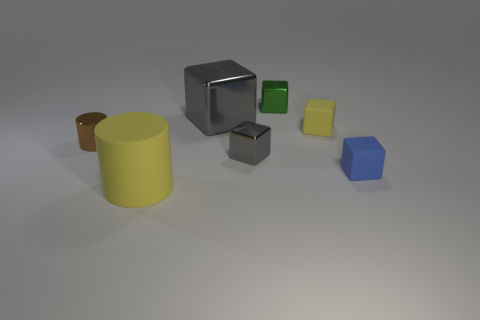There is a yellow object that is on the left side of the yellow object that is on the right side of the gray object that is in front of the brown object; what is it made of?
Ensure brevity in your answer.  Rubber. Does the green metal thing have the same shape as the blue matte thing?
Your response must be concise. Yes. What number of metal objects are either large purple spheres or yellow cubes?
Give a very brief answer. 0. What number of small cubes are there?
Make the answer very short. 4. There is another matte block that is the same size as the yellow matte block; what color is it?
Offer a terse response. Blue. Does the yellow cube have the same size as the green cube?
Your answer should be very brief. Yes. There is a blue matte cube; is its size the same as the yellow matte thing in front of the tiny blue matte block?
Provide a short and direct response. No. There is a block that is to the left of the green shiny thing and to the right of the large block; what is its color?
Provide a short and direct response. Gray. Are there more big yellow rubber things on the left side of the tiny green metal cube than large cylinders behind the blue rubber thing?
Provide a succinct answer. Yes. The green cube that is the same material as the brown object is what size?
Offer a very short reply. Small. 